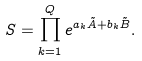Convert formula to latex. <formula><loc_0><loc_0><loc_500><loc_500>S = \prod _ { k = 1 } ^ { Q } e ^ { a _ { k } \tilde { A } + b _ { k } \tilde { B } } .</formula> 